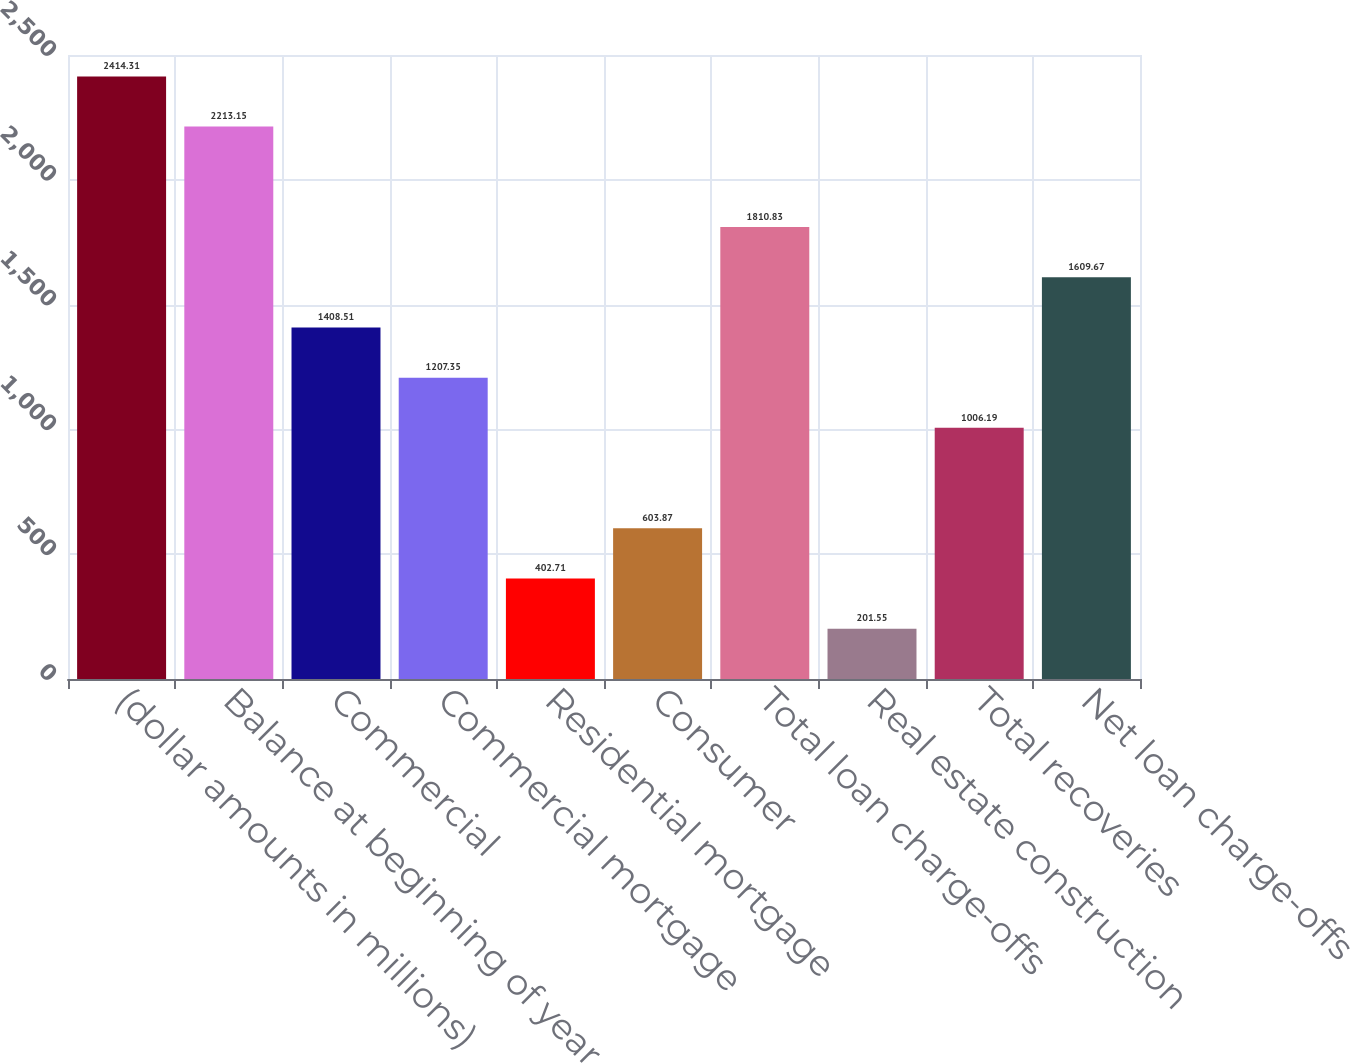<chart> <loc_0><loc_0><loc_500><loc_500><bar_chart><fcel>(dollar amounts in millions)<fcel>Balance at beginning of year<fcel>Commercial<fcel>Commercial mortgage<fcel>Residential mortgage<fcel>Consumer<fcel>Total loan charge-offs<fcel>Real estate construction<fcel>Total recoveries<fcel>Net loan charge-offs<nl><fcel>2414.31<fcel>2213.15<fcel>1408.51<fcel>1207.35<fcel>402.71<fcel>603.87<fcel>1810.83<fcel>201.55<fcel>1006.19<fcel>1609.67<nl></chart> 